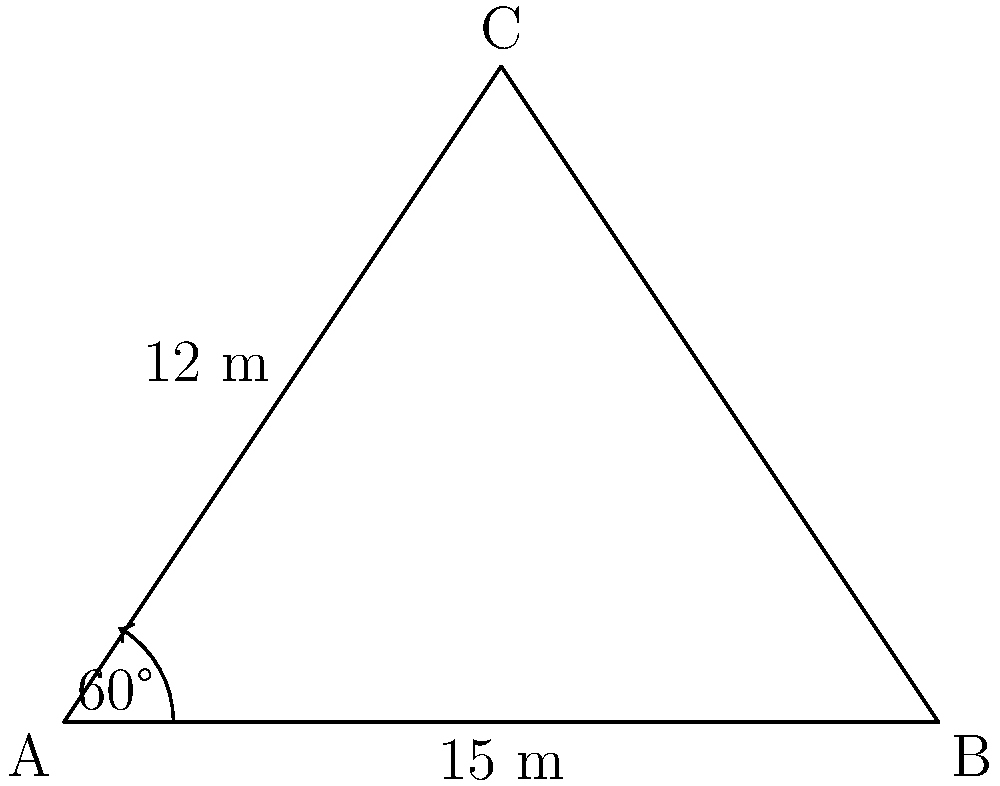Your puppy loves to run around the triangular backyard. Given that two sides of the yard measure 15 m and 12 m, with an angle of 60° between them, how far can your puppy run in a straight line from one corner to the opposite side of the yard? To solve this problem, we'll use the law of cosines. Let's break it down step by step:

1) We have a triangle with two known sides (a = 15 m, b = 12 m) and the angle between them (C = 60°).

2) We want to find the length of the third side (c), which is opposite to the given angle.

3) The law of cosines states: $c^2 = a^2 + b^2 - 2ab \cos(C)$

4) Let's substitute our known values:
   $c^2 = 15^2 + 12^2 - 2(15)(12) \cos(60°)$

5) Simplify:
   $c^2 = 225 + 144 - 360 \cos(60°)$

6) $\cos(60°) = 0.5$, so:
   $c^2 = 225 + 144 - 360(0.5) = 225 + 144 - 180 = 189$

7) Take the square root of both sides:
   $c = \sqrt{189} \approx 13.75$ m

Therefore, your puppy can run approximately 13.75 meters in a straight line from one corner to the opposite side of the yard.
Answer: 13.75 m 